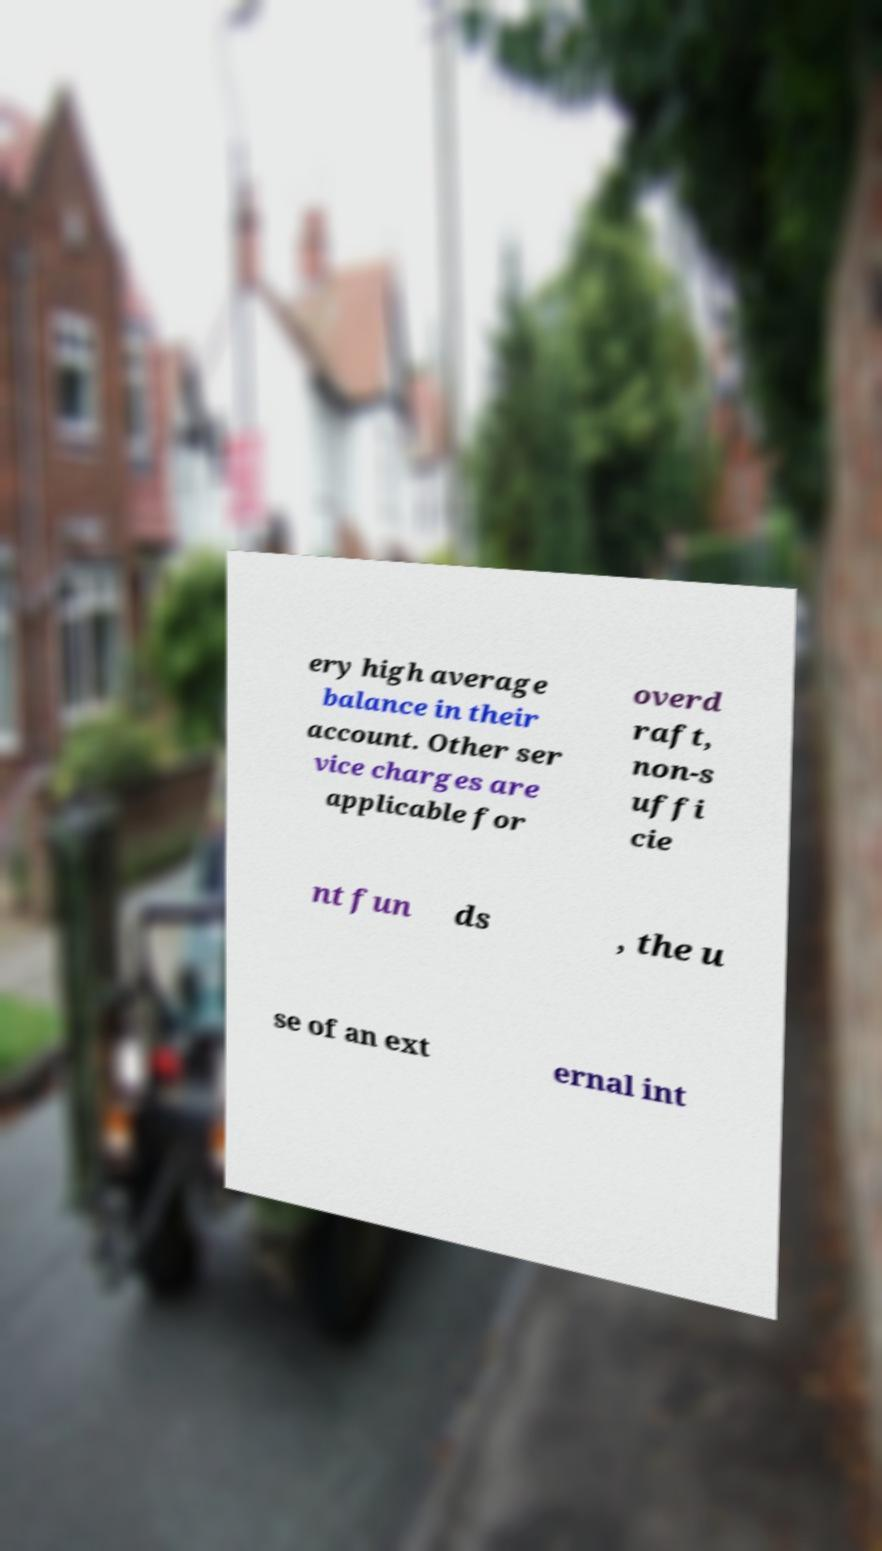Could you assist in decoding the text presented in this image and type it out clearly? ery high average balance in their account. Other ser vice charges are applicable for overd raft, non-s uffi cie nt fun ds , the u se of an ext ernal int 